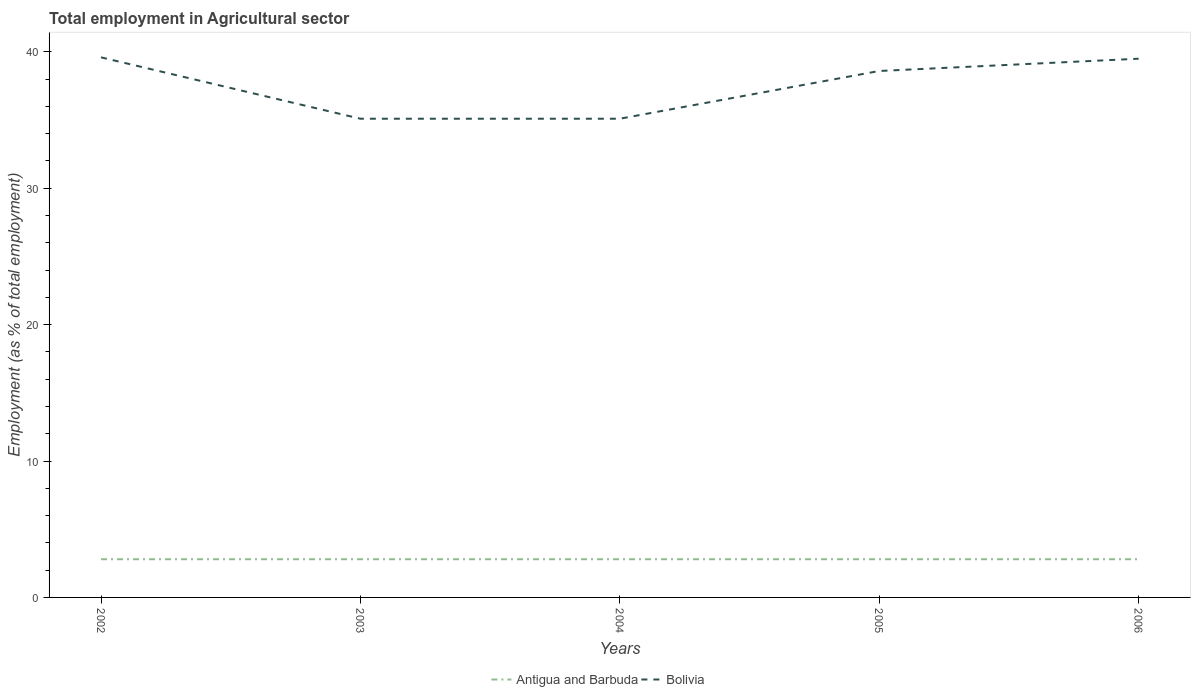How many different coloured lines are there?
Your answer should be compact. 2. Does the line corresponding to Antigua and Barbuda intersect with the line corresponding to Bolivia?
Your answer should be very brief. No. Is the number of lines equal to the number of legend labels?
Your answer should be very brief. Yes. Across all years, what is the maximum employment in agricultural sector in Antigua and Barbuda?
Provide a succinct answer. 2.8. How many lines are there?
Your response must be concise. 2. How many years are there in the graph?
Offer a terse response. 5. What is the difference between two consecutive major ticks on the Y-axis?
Your answer should be very brief. 10. Are the values on the major ticks of Y-axis written in scientific E-notation?
Your response must be concise. No. Does the graph contain any zero values?
Offer a very short reply. No. Does the graph contain grids?
Give a very brief answer. No. Where does the legend appear in the graph?
Your response must be concise. Bottom center. What is the title of the graph?
Make the answer very short. Total employment in Agricultural sector. Does "South Sudan" appear as one of the legend labels in the graph?
Your answer should be compact. No. What is the label or title of the X-axis?
Keep it short and to the point. Years. What is the label or title of the Y-axis?
Your answer should be compact. Employment (as % of total employment). What is the Employment (as % of total employment) in Antigua and Barbuda in 2002?
Make the answer very short. 2.8. What is the Employment (as % of total employment) of Bolivia in 2002?
Make the answer very short. 39.6. What is the Employment (as % of total employment) of Antigua and Barbuda in 2003?
Ensure brevity in your answer.  2.8. What is the Employment (as % of total employment) of Bolivia in 2003?
Offer a very short reply. 35.1. What is the Employment (as % of total employment) in Antigua and Barbuda in 2004?
Your answer should be compact. 2.8. What is the Employment (as % of total employment) in Bolivia in 2004?
Your response must be concise. 35.1. What is the Employment (as % of total employment) of Antigua and Barbuda in 2005?
Provide a short and direct response. 2.8. What is the Employment (as % of total employment) of Bolivia in 2005?
Offer a very short reply. 38.6. What is the Employment (as % of total employment) of Antigua and Barbuda in 2006?
Your answer should be very brief. 2.8. What is the Employment (as % of total employment) in Bolivia in 2006?
Your response must be concise. 39.5. Across all years, what is the maximum Employment (as % of total employment) of Antigua and Barbuda?
Keep it short and to the point. 2.8. Across all years, what is the maximum Employment (as % of total employment) in Bolivia?
Give a very brief answer. 39.6. Across all years, what is the minimum Employment (as % of total employment) in Antigua and Barbuda?
Your response must be concise. 2.8. Across all years, what is the minimum Employment (as % of total employment) in Bolivia?
Your response must be concise. 35.1. What is the total Employment (as % of total employment) in Antigua and Barbuda in the graph?
Make the answer very short. 14. What is the total Employment (as % of total employment) in Bolivia in the graph?
Offer a very short reply. 187.9. What is the difference between the Employment (as % of total employment) of Bolivia in 2002 and that in 2004?
Offer a terse response. 4.5. What is the difference between the Employment (as % of total employment) of Antigua and Barbuda in 2002 and that in 2005?
Provide a succinct answer. 0. What is the difference between the Employment (as % of total employment) in Bolivia in 2002 and that in 2005?
Provide a succinct answer. 1. What is the difference between the Employment (as % of total employment) of Antigua and Barbuda in 2003 and that in 2004?
Provide a short and direct response. 0. What is the difference between the Employment (as % of total employment) in Bolivia in 2003 and that in 2004?
Offer a terse response. 0. What is the difference between the Employment (as % of total employment) in Antigua and Barbuda in 2003 and that in 2005?
Keep it short and to the point. 0. What is the difference between the Employment (as % of total employment) of Bolivia in 2003 and that in 2006?
Provide a succinct answer. -4.4. What is the difference between the Employment (as % of total employment) of Antigua and Barbuda in 2004 and that in 2005?
Offer a very short reply. 0. What is the difference between the Employment (as % of total employment) of Bolivia in 2004 and that in 2005?
Your response must be concise. -3.5. What is the difference between the Employment (as % of total employment) in Bolivia in 2004 and that in 2006?
Give a very brief answer. -4.4. What is the difference between the Employment (as % of total employment) in Bolivia in 2005 and that in 2006?
Make the answer very short. -0.9. What is the difference between the Employment (as % of total employment) of Antigua and Barbuda in 2002 and the Employment (as % of total employment) of Bolivia in 2003?
Your answer should be compact. -32.3. What is the difference between the Employment (as % of total employment) of Antigua and Barbuda in 2002 and the Employment (as % of total employment) of Bolivia in 2004?
Provide a short and direct response. -32.3. What is the difference between the Employment (as % of total employment) of Antigua and Barbuda in 2002 and the Employment (as % of total employment) of Bolivia in 2005?
Give a very brief answer. -35.8. What is the difference between the Employment (as % of total employment) in Antigua and Barbuda in 2002 and the Employment (as % of total employment) in Bolivia in 2006?
Offer a terse response. -36.7. What is the difference between the Employment (as % of total employment) of Antigua and Barbuda in 2003 and the Employment (as % of total employment) of Bolivia in 2004?
Offer a very short reply. -32.3. What is the difference between the Employment (as % of total employment) in Antigua and Barbuda in 2003 and the Employment (as % of total employment) in Bolivia in 2005?
Your response must be concise. -35.8. What is the difference between the Employment (as % of total employment) of Antigua and Barbuda in 2003 and the Employment (as % of total employment) of Bolivia in 2006?
Keep it short and to the point. -36.7. What is the difference between the Employment (as % of total employment) of Antigua and Barbuda in 2004 and the Employment (as % of total employment) of Bolivia in 2005?
Give a very brief answer. -35.8. What is the difference between the Employment (as % of total employment) of Antigua and Barbuda in 2004 and the Employment (as % of total employment) of Bolivia in 2006?
Your answer should be very brief. -36.7. What is the difference between the Employment (as % of total employment) in Antigua and Barbuda in 2005 and the Employment (as % of total employment) in Bolivia in 2006?
Offer a terse response. -36.7. What is the average Employment (as % of total employment) of Antigua and Barbuda per year?
Your response must be concise. 2.8. What is the average Employment (as % of total employment) in Bolivia per year?
Your response must be concise. 37.58. In the year 2002, what is the difference between the Employment (as % of total employment) in Antigua and Barbuda and Employment (as % of total employment) in Bolivia?
Provide a succinct answer. -36.8. In the year 2003, what is the difference between the Employment (as % of total employment) in Antigua and Barbuda and Employment (as % of total employment) in Bolivia?
Give a very brief answer. -32.3. In the year 2004, what is the difference between the Employment (as % of total employment) of Antigua and Barbuda and Employment (as % of total employment) of Bolivia?
Offer a very short reply. -32.3. In the year 2005, what is the difference between the Employment (as % of total employment) in Antigua and Barbuda and Employment (as % of total employment) in Bolivia?
Give a very brief answer. -35.8. In the year 2006, what is the difference between the Employment (as % of total employment) of Antigua and Barbuda and Employment (as % of total employment) of Bolivia?
Your answer should be compact. -36.7. What is the ratio of the Employment (as % of total employment) in Antigua and Barbuda in 2002 to that in 2003?
Offer a very short reply. 1. What is the ratio of the Employment (as % of total employment) in Bolivia in 2002 to that in 2003?
Offer a very short reply. 1.13. What is the ratio of the Employment (as % of total employment) in Antigua and Barbuda in 2002 to that in 2004?
Give a very brief answer. 1. What is the ratio of the Employment (as % of total employment) in Bolivia in 2002 to that in 2004?
Offer a terse response. 1.13. What is the ratio of the Employment (as % of total employment) of Bolivia in 2002 to that in 2005?
Your answer should be very brief. 1.03. What is the ratio of the Employment (as % of total employment) in Antigua and Barbuda in 2003 to that in 2004?
Offer a very short reply. 1. What is the ratio of the Employment (as % of total employment) of Bolivia in 2003 to that in 2004?
Provide a short and direct response. 1. What is the ratio of the Employment (as % of total employment) in Antigua and Barbuda in 2003 to that in 2005?
Your answer should be very brief. 1. What is the ratio of the Employment (as % of total employment) of Bolivia in 2003 to that in 2005?
Ensure brevity in your answer.  0.91. What is the ratio of the Employment (as % of total employment) of Bolivia in 2003 to that in 2006?
Provide a succinct answer. 0.89. What is the ratio of the Employment (as % of total employment) of Bolivia in 2004 to that in 2005?
Keep it short and to the point. 0.91. What is the ratio of the Employment (as % of total employment) of Antigua and Barbuda in 2004 to that in 2006?
Provide a succinct answer. 1. What is the ratio of the Employment (as % of total employment) of Bolivia in 2004 to that in 2006?
Make the answer very short. 0.89. What is the ratio of the Employment (as % of total employment) in Antigua and Barbuda in 2005 to that in 2006?
Provide a succinct answer. 1. What is the ratio of the Employment (as % of total employment) of Bolivia in 2005 to that in 2006?
Make the answer very short. 0.98. What is the difference between the highest and the second highest Employment (as % of total employment) of Antigua and Barbuda?
Provide a short and direct response. 0. What is the difference between the highest and the second highest Employment (as % of total employment) in Bolivia?
Your answer should be compact. 0.1. What is the difference between the highest and the lowest Employment (as % of total employment) in Bolivia?
Ensure brevity in your answer.  4.5. 